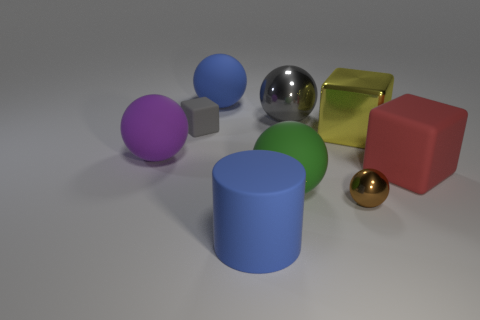Subtract all small gray cubes. How many cubes are left? 2 Subtract all gray spheres. How many spheres are left? 4 Subtract 2 balls. How many balls are left? 3 Subtract all brown balls. Subtract all red cubes. How many balls are left? 4 Subtract all blocks. How many objects are left? 6 Add 1 gray metallic objects. How many gray metallic objects are left? 2 Add 3 big red rubber cubes. How many big red rubber cubes exist? 4 Subtract 0 green blocks. How many objects are left? 9 Subtract all big red metallic cylinders. Subtract all brown metal balls. How many objects are left? 8 